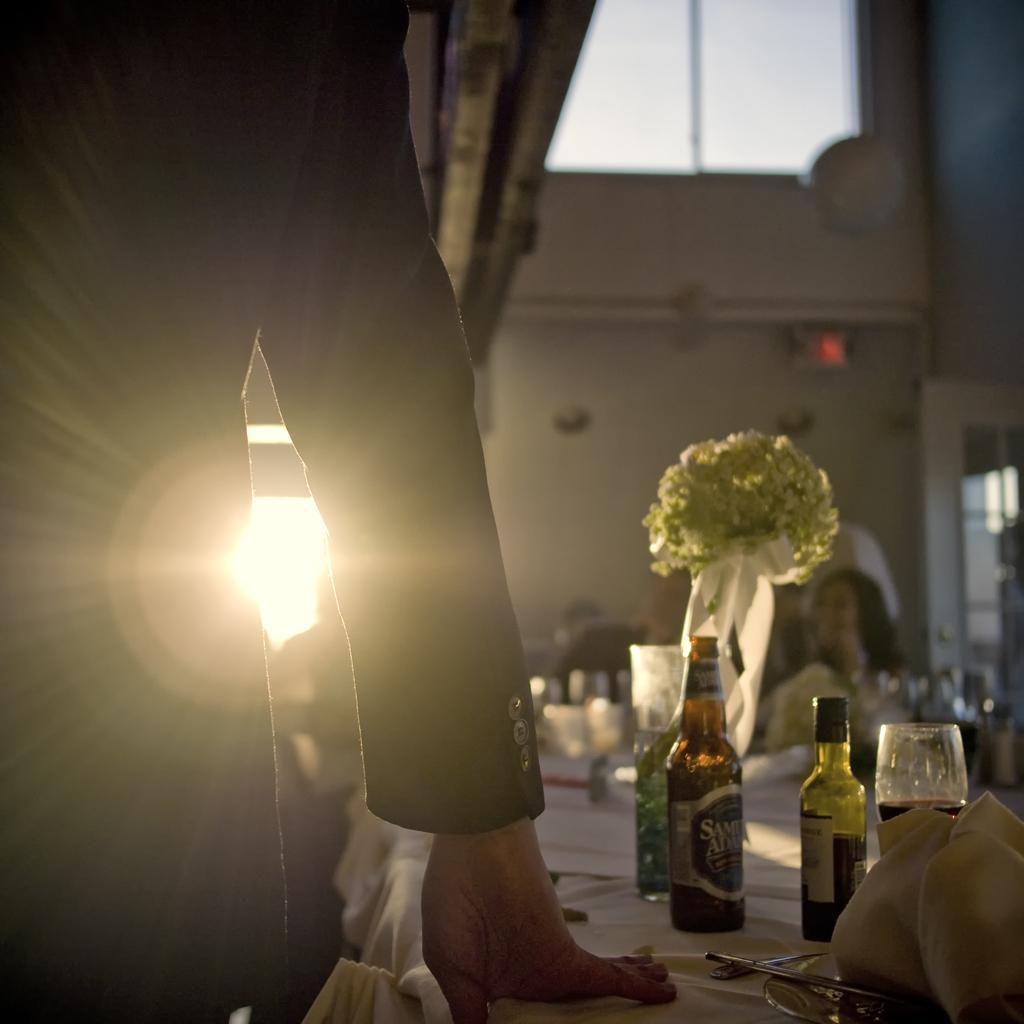How would you summarize this image in a sentence or two? In the image on the left we can see one man standing. On the right there is a table,on table we can see glass,wine bottle,flower vase etc. In the background there is a wall,curtain and few persons were sitting on the chair. 